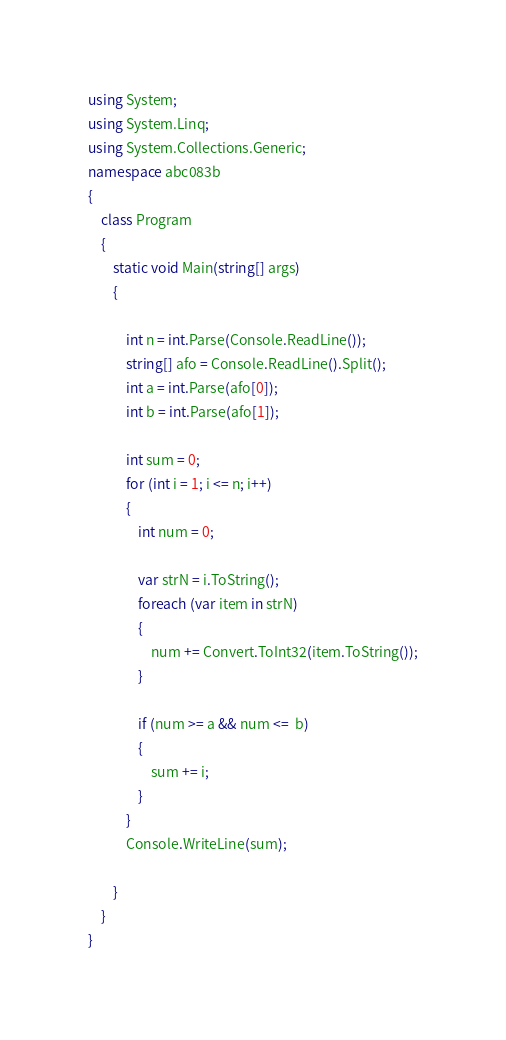<code> <loc_0><loc_0><loc_500><loc_500><_C#_>using System;
using System.Linq;
using System.Collections.Generic;
namespace abc083b
{
    class Program
    {
        static void Main(string[] args)
        {
            
            int n = int.Parse(Console.ReadLine());
            string[] afo = Console.ReadLine().Split();
            int a = int.Parse(afo[0]);
            int b = int.Parse(afo[1]);

            int sum = 0;
            for (int i = 1; i <= n; i++)
            {
                int num = 0;

                var strN = i.ToString();
                foreach (var item in strN)
                {
                    num += Convert.ToInt32(item.ToString());
                }

                if (num >= a && num <=  b)
                {
                    sum += i;
                }
            }
            Console.WriteLine(sum);

        }
    }
}
</code> 